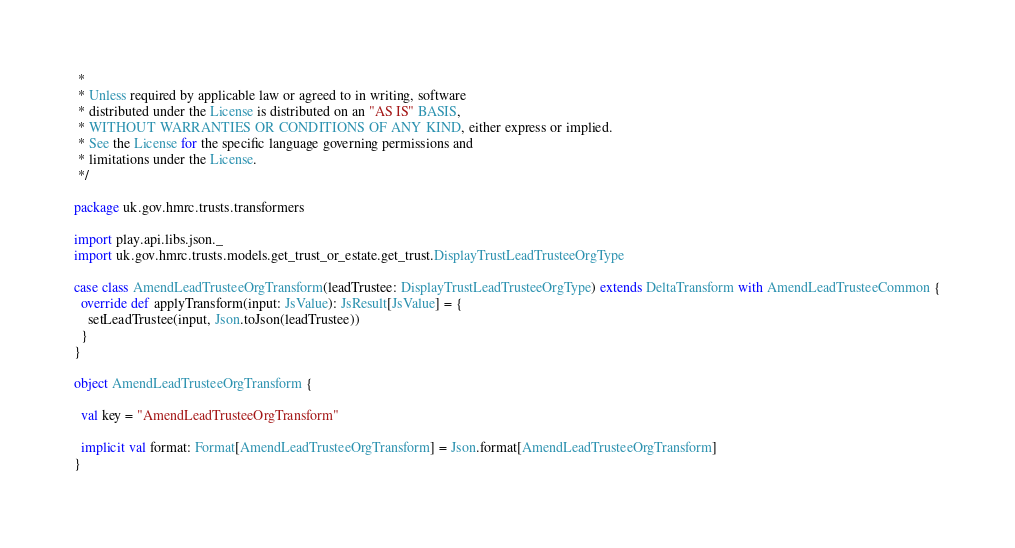<code> <loc_0><loc_0><loc_500><loc_500><_Scala_> *
 * Unless required by applicable law or agreed to in writing, software
 * distributed under the License is distributed on an "AS IS" BASIS,
 * WITHOUT WARRANTIES OR CONDITIONS OF ANY KIND, either express or implied.
 * See the License for the specific language governing permissions and
 * limitations under the License.
 */

package uk.gov.hmrc.trusts.transformers

import play.api.libs.json._
import uk.gov.hmrc.trusts.models.get_trust_or_estate.get_trust.DisplayTrustLeadTrusteeOrgType

case class AmendLeadTrusteeOrgTransform(leadTrustee: DisplayTrustLeadTrusteeOrgType) extends DeltaTransform with AmendLeadTrusteeCommon {
  override def applyTransform(input: JsValue): JsResult[JsValue] = {
    setLeadTrustee(input, Json.toJson(leadTrustee))
  }
}

object AmendLeadTrusteeOrgTransform {

  val key = "AmendLeadTrusteeOrgTransform"

  implicit val format: Format[AmendLeadTrusteeOrgTransform] = Json.format[AmendLeadTrusteeOrgTransform]
}
</code> 